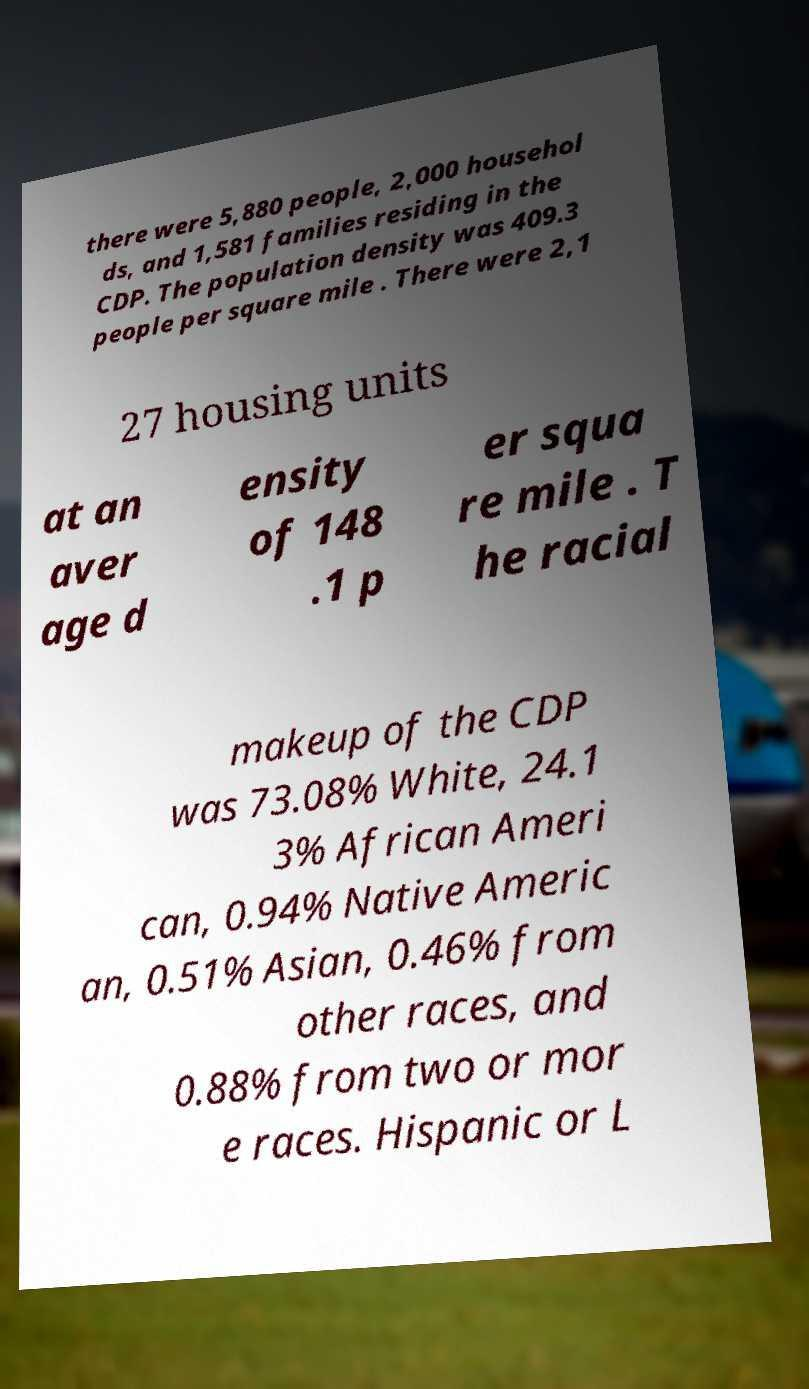I need the written content from this picture converted into text. Can you do that? there were 5,880 people, 2,000 househol ds, and 1,581 families residing in the CDP. The population density was 409.3 people per square mile . There were 2,1 27 housing units at an aver age d ensity of 148 .1 p er squa re mile . T he racial makeup of the CDP was 73.08% White, 24.1 3% African Ameri can, 0.94% Native Americ an, 0.51% Asian, 0.46% from other races, and 0.88% from two or mor e races. Hispanic or L 